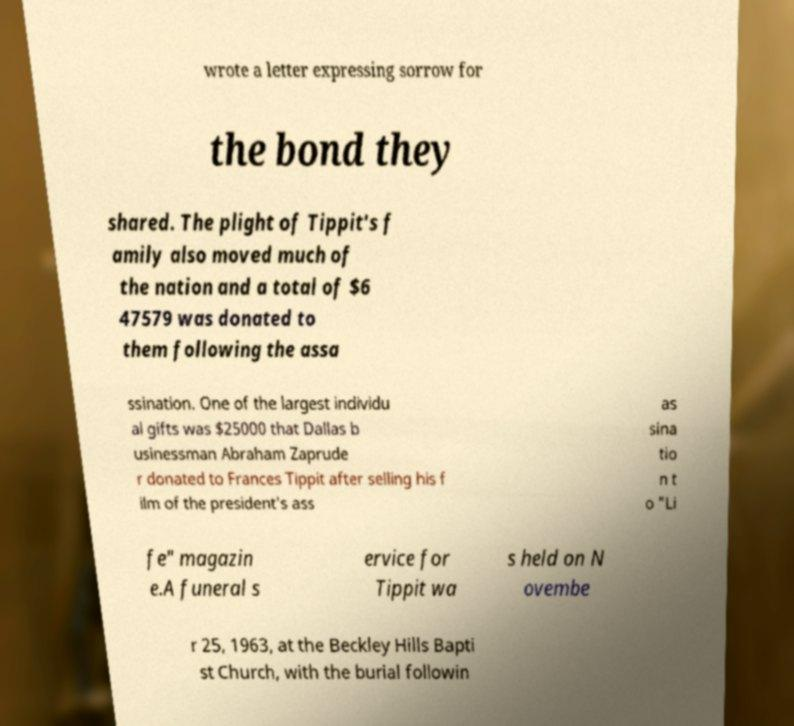There's text embedded in this image that I need extracted. Can you transcribe it verbatim? wrote a letter expressing sorrow for the bond they shared. The plight of Tippit's f amily also moved much of the nation and a total of $6 47579 was donated to them following the assa ssination. One of the largest individu al gifts was $25000 that Dallas b usinessman Abraham Zaprude r donated to Frances Tippit after selling his f ilm of the president's ass as sina tio n t o "Li fe" magazin e.A funeral s ervice for Tippit wa s held on N ovembe r 25, 1963, at the Beckley Hills Bapti st Church, with the burial followin 